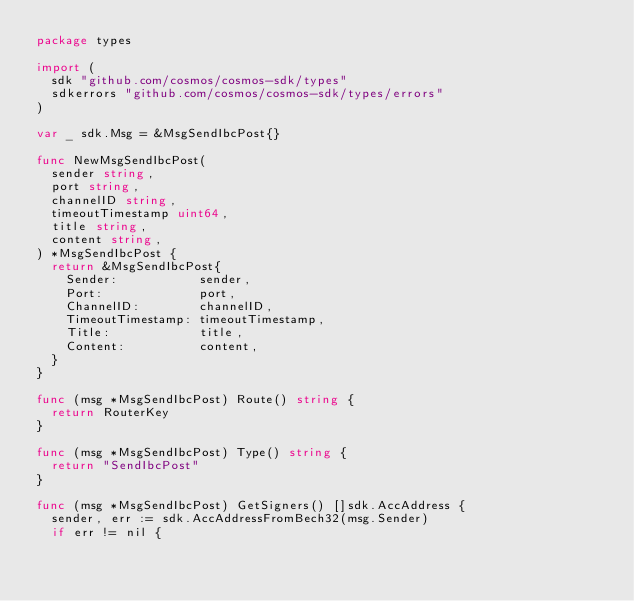<code> <loc_0><loc_0><loc_500><loc_500><_Go_>package types

import (
	sdk "github.com/cosmos/cosmos-sdk/types"
	sdkerrors "github.com/cosmos/cosmos-sdk/types/errors"
)

var _ sdk.Msg = &MsgSendIbcPost{}

func NewMsgSendIbcPost(
	sender string,
	port string,
	channelID string,
	timeoutTimestamp uint64,
	title string,
	content string,
) *MsgSendIbcPost {
	return &MsgSendIbcPost{
		Sender:           sender,
		Port:             port,
		ChannelID:        channelID,
		TimeoutTimestamp: timeoutTimestamp,
		Title:            title,
		Content:          content,
	}
}

func (msg *MsgSendIbcPost) Route() string {
	return RouterKey
}

func (msg *MsgSendIbcPost) Type() string {
	return "SendIbcPost"
}

func (msg *MsgSendIbcPost) GetSigners() []sdk.AccAddress {
	sender, err := sdk.AccAddressFromBech32(msg.Sender)
	if err != nil {</code> 